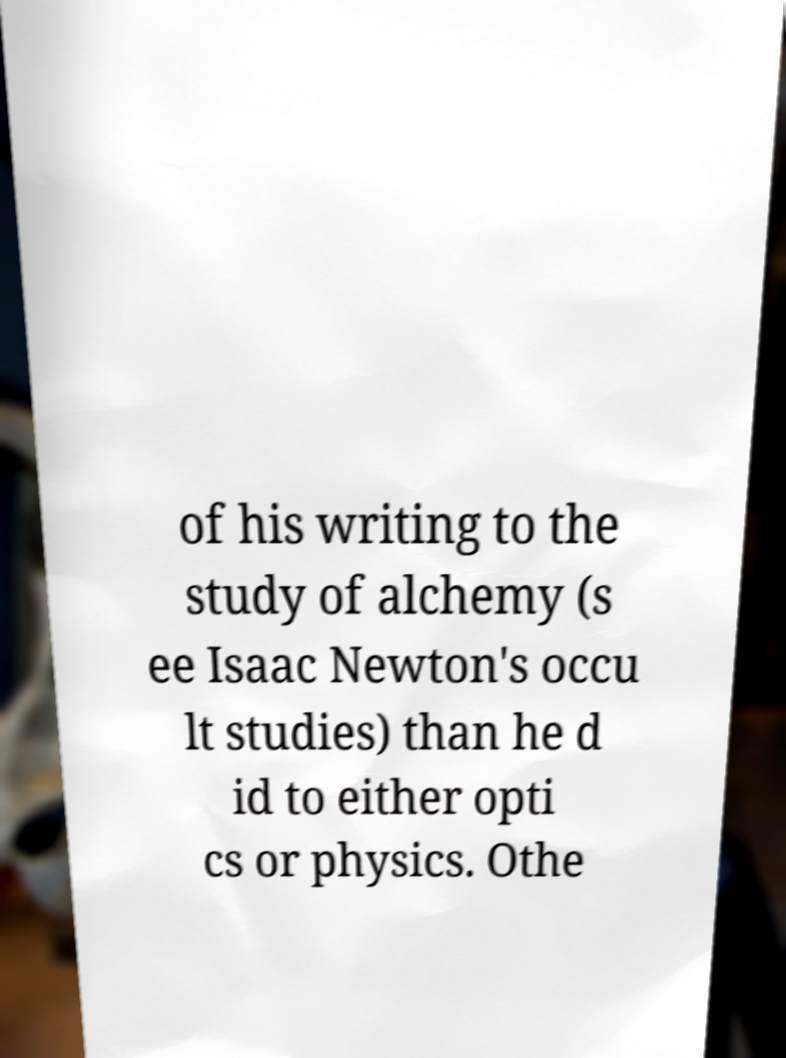Can you read and provide the text displayed in the image?This photo seems to have some interesting text. Can you extract and type it out for me? of his writing to the study of alchemy (s ee Isaac Newton's occu lt studies) than he d id to either opti cs or physics. Othe 